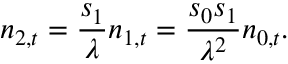<formula> <loc_0><loc_0><loc_500><loc_500>n _ { 2 , t } = { \frac { s _ { 1 } } { \lambda } } n _ { 1 , t } = { \frac { s _ { 0 } s _ { 1 } } { \lambda ^ { 2 } } } n _ { 0 , t } .</formula> 